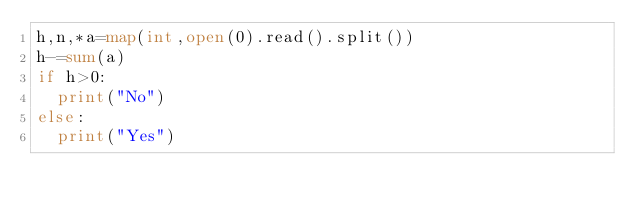Convert code to text. <code><loc_0><loc_0><loc_500><loc_500><_Python_>h,n,*a=map(int,open(0).read().split())
h-=sum(a)
if h>0:
  print("No")
else:
  print("Yes")</code> 